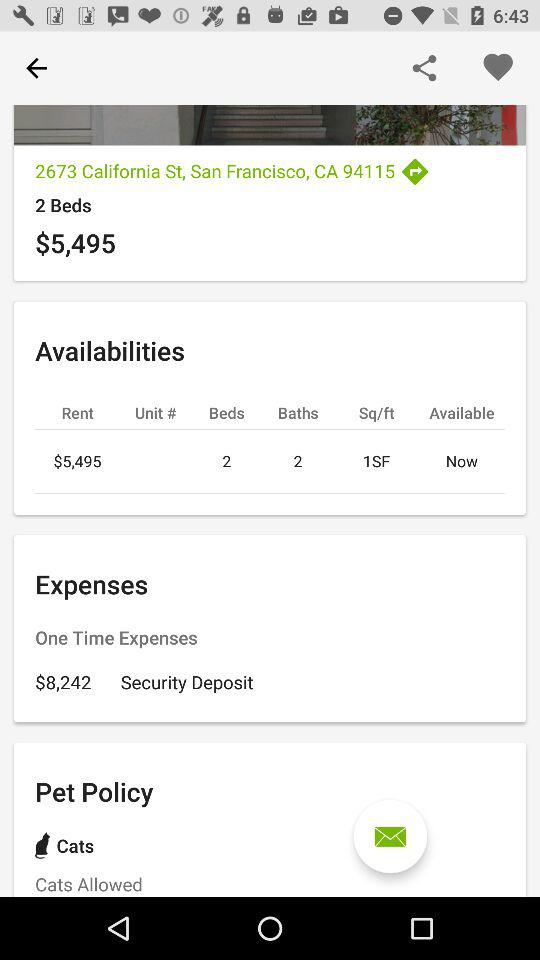How many beds does the apartment have?
Answer the question using a single word or phrase. 2 